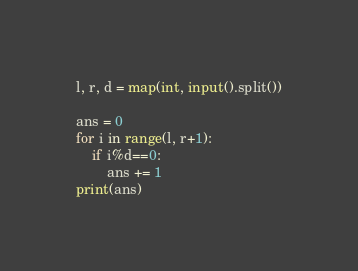<code> <loc_0><loc_0><loc_500><loc_500><_Python_>l, r, d = map(int, input().split())

ans = 0
for i in range(l, r+1):
    if i%d==0:
        ans += 1
print(ans)</code> 